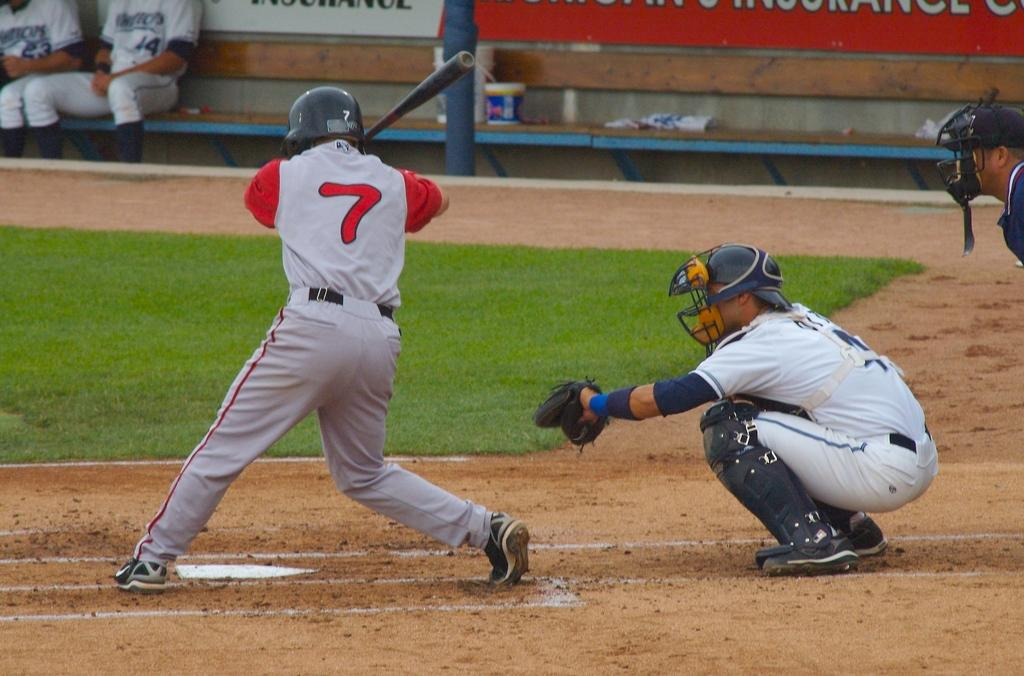Provide a one-sentence caption for the provided image. number 7 in red and gray ready to bat and catcher in white ready to catch the pitch. 